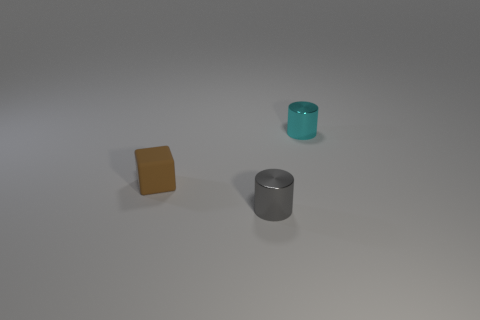Add 1 cyan balls. How many objects exist? 4 Subtract all cylinders. How many objects are left? 1 Add 3 brown matte things. How many brown matte things exist? 4 Subtract 0 purple blocks. How many objects are left? 3 Subtract all gray rubber spheres. Subtract all metallic cylinders. How many objects are left? 1 Add 3 tiny cyan metal cylinders. How many tiny cyan metal cylinders are left? 4 